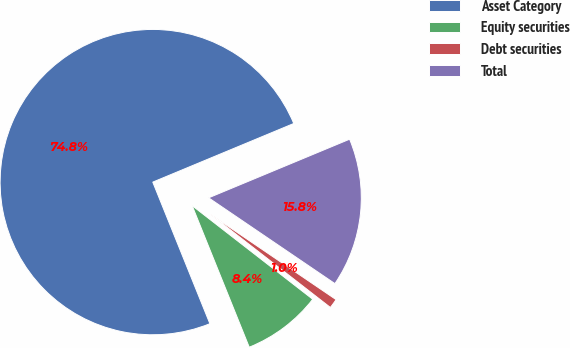<chart> <loc_0><loc_0><loc_500><loc_500><pie_chart><fcel>Asset Category<fcel>Equity securities<fcel>Debt securities<fcel>Total<nl><fcel>74.83%<fcel>8.39%<fcel>1.01%<fcel>15.77%<nl></chart> 